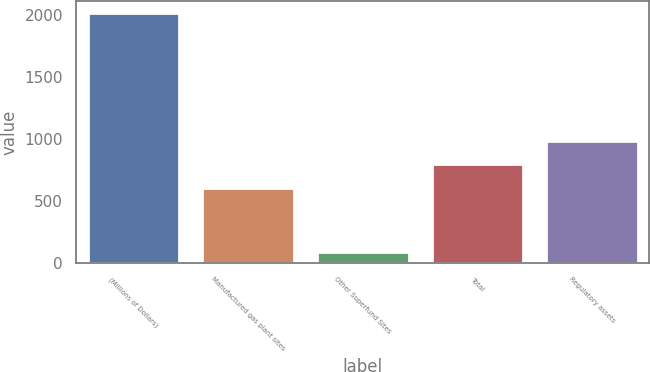Convert chart. <chart><loc_0><loc_0><loc_500><loc_500><bar_chart><fcel>(Millions of Dollars)<fcel>Manufactured gas plant sites<fcel>Other Superfund Sites<fcel>Total<fcel>Regulatory assets<nl><fcel>2018<fcel>603<fcel>90<fcel>795.8<fcel>988.6<nl></chart> 